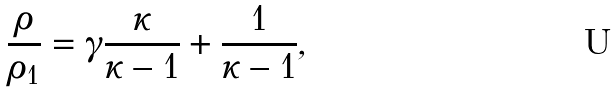<formula> <loc_0><loc_0><loc_500><loc_500>\frac { \rho } { \rho _ { 1 } } = \gamma \frac { \kappa } { \kappa - 1 } + \frac { 1 } { \kappa - 1 } ,</formula> 